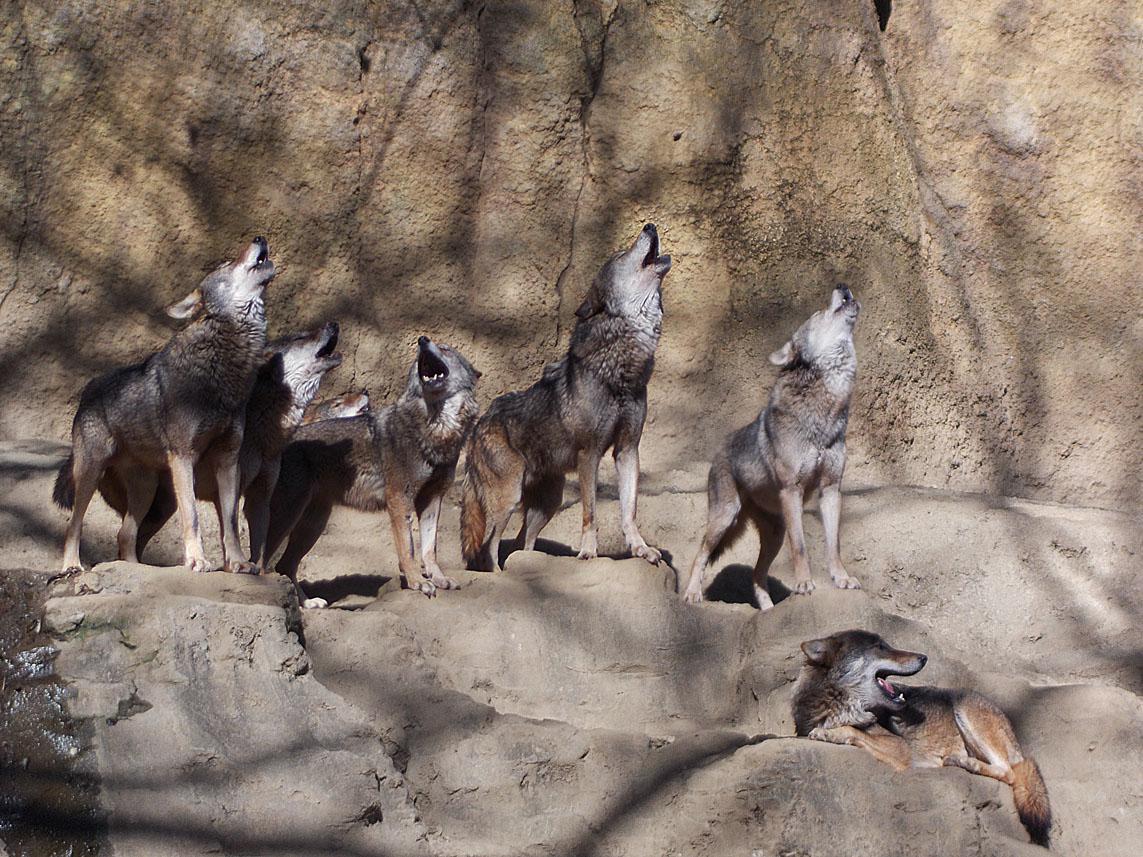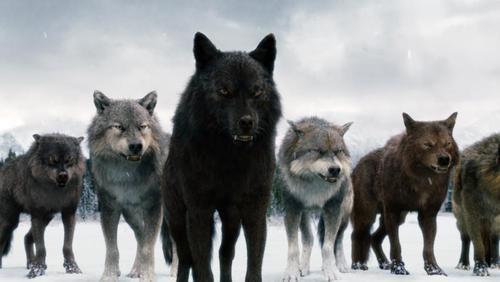The first image is the image on the left, the second image is the image on the right. Analyze the images presented: Is the assertion "The image on the left contains at least five wolves that are howling." valid? Answer yes or no. Yes. The first image is the image on the left, the second image is the image on the right. Assess this claim about the two images: "There are some wolves with white necks that have their heads titled up and are howling.". Correct or not? Answer yes or no. Yes. 